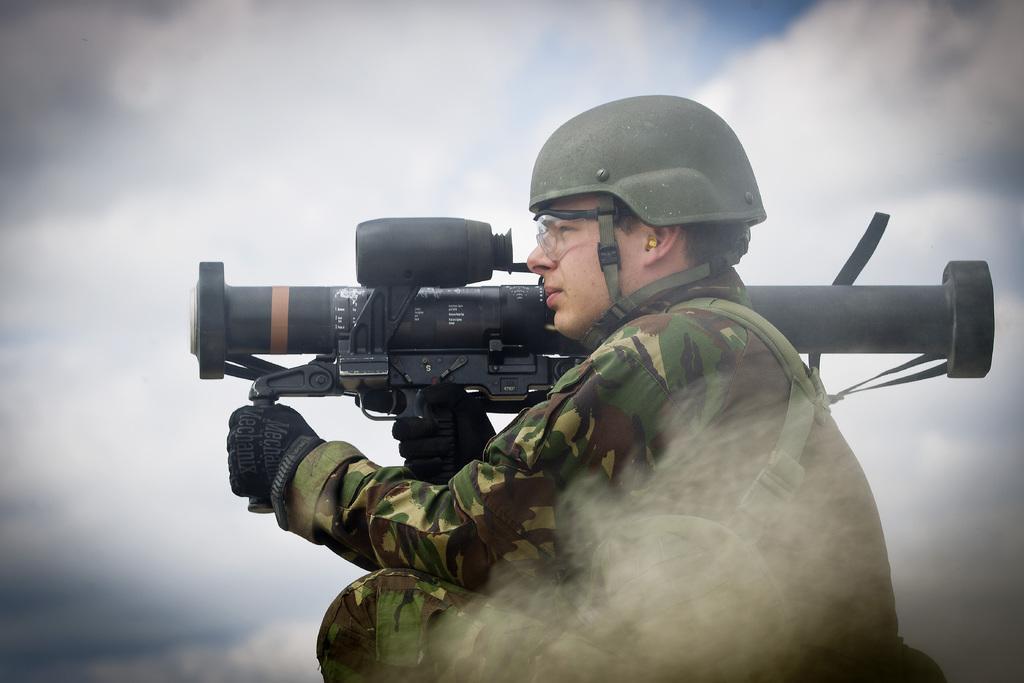How would you summarize this image in a sentence or two? In this image we can see this person is wearing a uniform, helmet, glasses and gloves is holding a weapon in his hands. Here we can see the smoke. In the background, we can see the cloudy sky. 